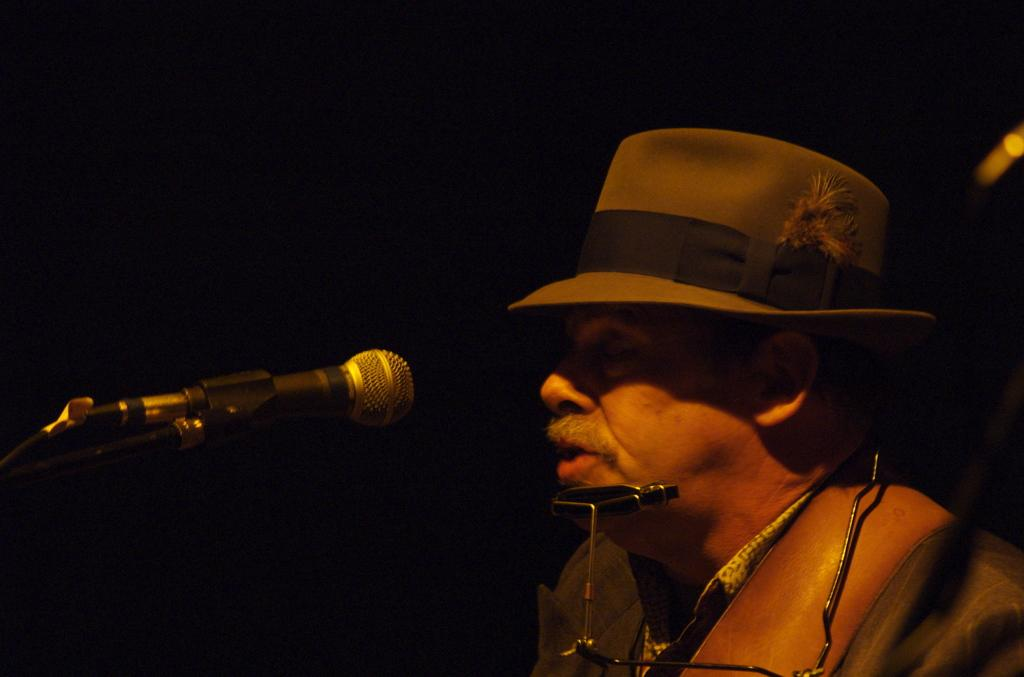Who or what is the main subject in the image? There is a person in the image. What is the person doing or interacting with in the image? The person is in front of a microphone. What type of expert is the squirrel in the image? There is no squirrel present in the image, so it is not possible to determine what type of expert the squirrel might be. 